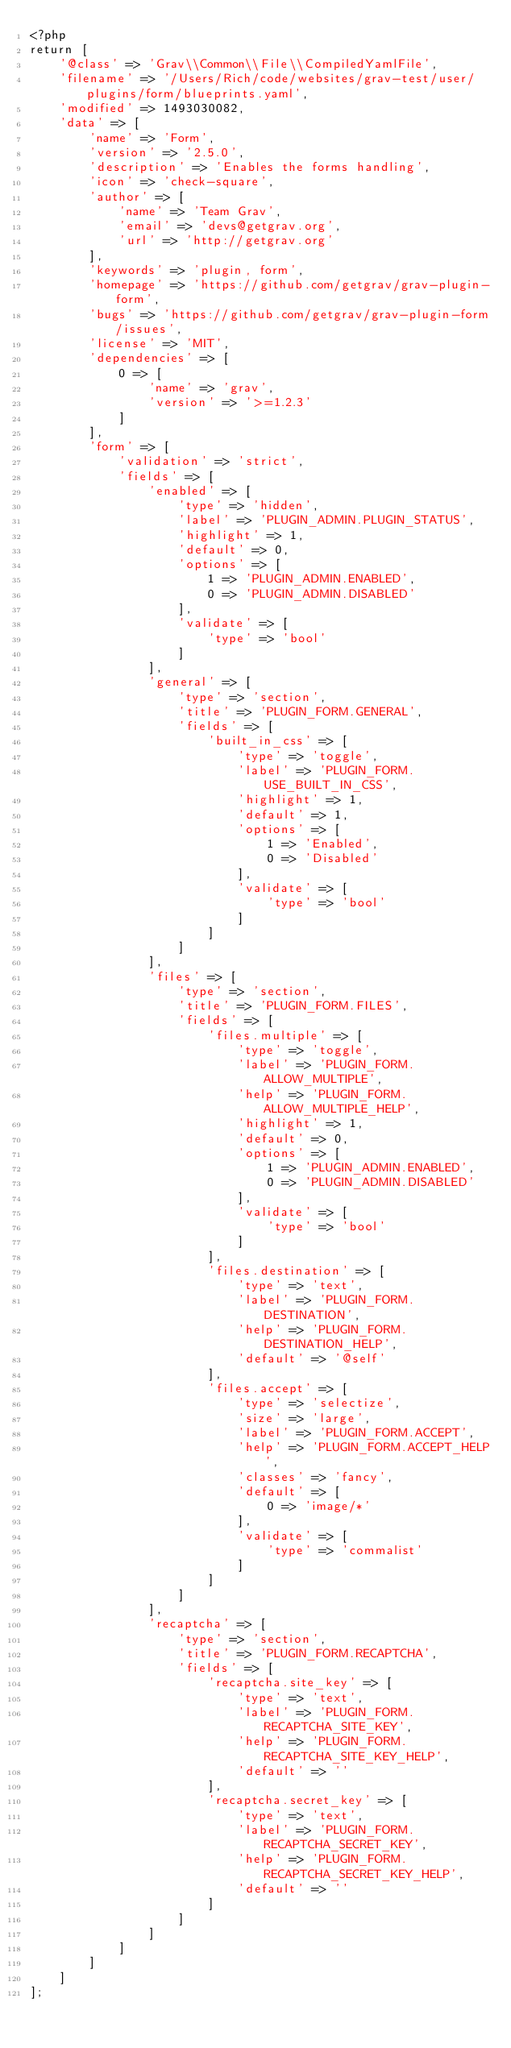<code> <loc_0><loc_0><loc_500><loc_500><_PHP_><?php
return [
    '@class' => 'Grav\\Common\\File\\CompiledYamlFile',
    'filename' => '/Users/Rich/code/websites/grav-test/user/plugins/form/blueprints.yaml',
    'modified' => 1493030082,
    'data' => [
        'name' => 'Form',
        'version' => '2.5.0',
        'description' => 'Enables the forms handling',
        'icon' => 'check-square',
        'author' => [
            'name' => 'Team Grav',
            'email' => 'devs@getgrav.org',
            'url' => 'http://getgrav.org'
        ],
        'keywords' => 'plugin, form',
        'homepage' => 'https://github.com/getgrav/grav-plugin-form',
        'bugs' => 'https://github.com/getgrav/grav-plugin-form/issues',
        'license' => 'MIT',
        'dependencies' => [
            0 => [
                'name' => 'grav',
                'version' => '>=1.2.3'
            ]
        ],
        'form' => [
            'validation' => 'strict',
            'fields' => [
                'enabled' => [
                    'type' => 'hidden',
                    'label' => 'PLUGIN_ADMIN.PLUGIN_STATUS',
                    'highlight' => 1,
                    'default' => 0,
                    'options' => [
                        1 => 'PLUGIN_ADMIN.ENABLED',
                        0 => 'PLUGIN_ADMIN.DISABLED'
                    ],
                    'validate' => [
                        'type' => 'bool'
                    ]
                ],
                'general' => [
                    'type' => 'section',
                    'title' => 'PLUGIN_FORM.GENERAL',
                    'fields' => [
                        'built_in_css' => [
                            'type' => 'toggle',
                            'label' => 'PLUGIN_FORM.USE_BUILT_IN_CSS',
                            'highlight' => 1,
                            'default' => 1,
                            'options' => [
                                1 => 'Enabled',
                                0 => 'Disabled'
                            ],
                            'validate' => [
                                'type' => 'bool'
                            ]
                        ]
                    ]
                ],
                'files' => [
                    'type' => 'section',
                    'title' => 'PLUGIN_FORM.FILES',
                    'fields' => [
                        'files.multiple' => [
                            'type' => 'toggle',
                            'label' => 'PLUGIN_FORM.ALLOW_MULTIPLE',
                            'help' => 'PLUGIN_FORM.ALLOW_MULTIPLE_HELP',
                            'highlight' => 1,
                            'default' => 0,
                            'options' => [
                                1 => 'PLUGIN_ADMIN.ENABLED',
                                0 => 'PLUGIN_ADMIN.DISABLED'
                            ],
                            'validate' => [
                                'type' => 'bool'
                            ]
                        ],
                        'files.destination' => [
                            'type' => 'text',
                            'label' => 'PLUGIN_FORM.DESTINATION',
                            'help' => 'PLUGIN_FORM.DESTINATION_HELP',
                            'default' => '@self'
                        ],
                        'files.accept' => [
                            'type' => 'selectize',
                            'size' => 'large',
                            'label' => 'PLUGIN_FORM.ACCEPT',
                            'help' => 'PLUGIN_FORM.ACCEPT_HELP',
                            'classes' => 'fancy',
                            'default' => [
                                0 => 'image/*'
                            ],
                            'validate' => [
                                'type' => 'commalist'
                            ]
                        ]
                    ]
                ],
                'recaptcha' => [
                    'type' => 'section',
                    'title' => 'PLUGIN_FORM.RECAPTCHA',
                    'fields' => [
                        'recaptcha.site_key' => [
                            'type' => 'text',
                            'label' => 'PLUGIN_FORM.RECAPTCHA_SITE_KEY',
                            'help' => 'PLUGIN_FORM.RECAPTCHA_SITE_KEY_HELP',
                            'default' => ''
                        ],
                        'recaptcha.secret_key' => [
                            'type' => 'text',
                            'label' => 'PLUGIN_FORM.RECAPTCHA_SECRET_KEY',
                            'help' => 'PLUGIN_FORM.RECAPTCHA_SECRET_KEY_HELP',
                            'default' => ''
                        ]
                    ]
                ]
            ]
        ]
    ]
];
</code> 